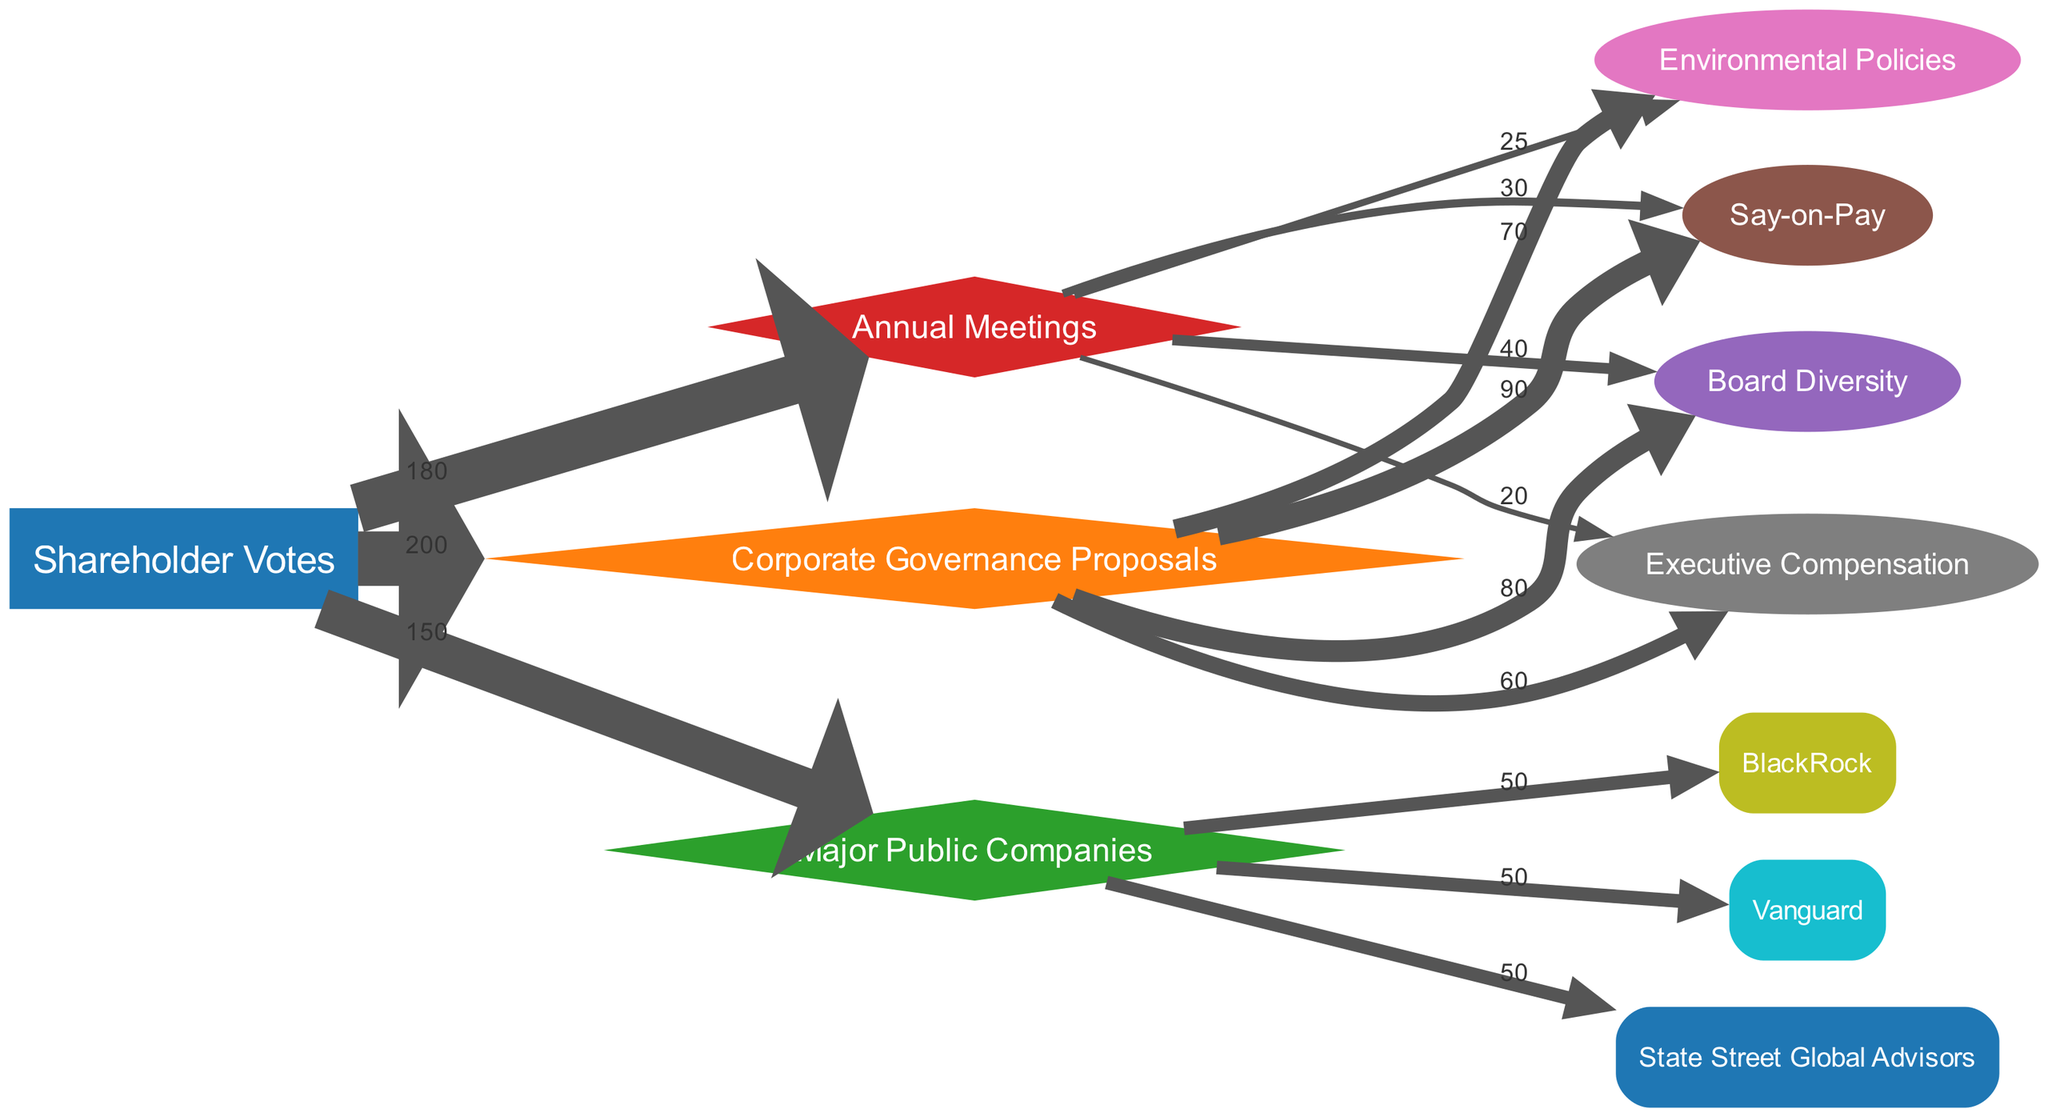What is the total number of shareholder votes represented in the diagram? The diagram indicates that there are 200 shareholder votes linked to the Corporate Governance Proposals node, which is considered the total for that category.
Answer: 200 Which corporate governance proposal received the most votes? By examining the weights of the links from Corporate Governance Proposals, Say-on-Pay has the highest value of 90, indicating it received the most votes.
Answer: Say-on-Pay How many issues are connected to annual meetings? The Annual Meetings node has connections to four issues: Board Diversity, Say-on-Pay, Environmental Policies, and Executive Compensation, totaling four issues.
Answer: 4 Which company received an equal number of votes as the other two companies? The links from Major Public Companies show that BlackRock, Vanguard, and State Street Global Advisors each have a value of 50 votes, indicating they received equal votes.
Answer: BlackRock, Vanguard, State Street Global Advisors What percentage of total votes is represented by Board Diversity proposals? Board Diversity has 80 votes from a total of 200. Therefore, the percentage is (80/200) * 100 = 40%.
Answer: 40% Which issue is linked with the fewest votes in relation to annual meetings? The connections from Annual Meetings reveal that Executive Compensation has the lowest value of 20, implying it is linked with the fewest votes.
Answer: Executive Compensation Which corporate governance proposal has the least linkage to both shareholder votes and annual meetings combined? Environmental Policies received 70 votes in total from Corporate Governance Proposals and 25 votes from Annual Meetings, totaling 95. Comparing with other proposals, it is the least combined number.
Answer: Environmental Policies Which category has the highest total value from the votes linked to it? Summing the values: Corporate Governance Proposals (200), Major Public Companies (150), and Annual Meetings (180), Corporate Governance Proposals has the highest individual linkage total of 200.
Answer: Corporate Governance Proposals 